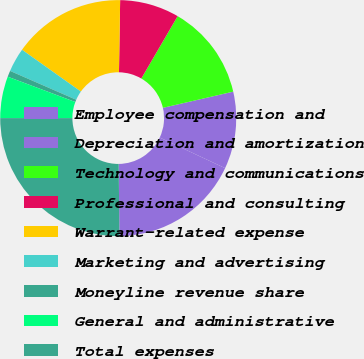<chart> <loc_0><loc_0><loc_500><loc_500><pie_chart><fcel>Employee compensation and<fcel>Depreciation and amortization<fcel>Technology and communications<fcel>Professional and consulting<fcel>Warrant-related expense<fcel>Marketing and advertising<fcel>Moneyline revenue share<fcel>General and administrative<fcel>Total expenses<nl><fcel>17.87%<fcel>10.57%<fcel>13.0%<fcel>8.14%<fcel>15.43%<fcel>3.28%<fcel>0.84%<fcel>5.71%<fcel>25.16%<nl></chart> 